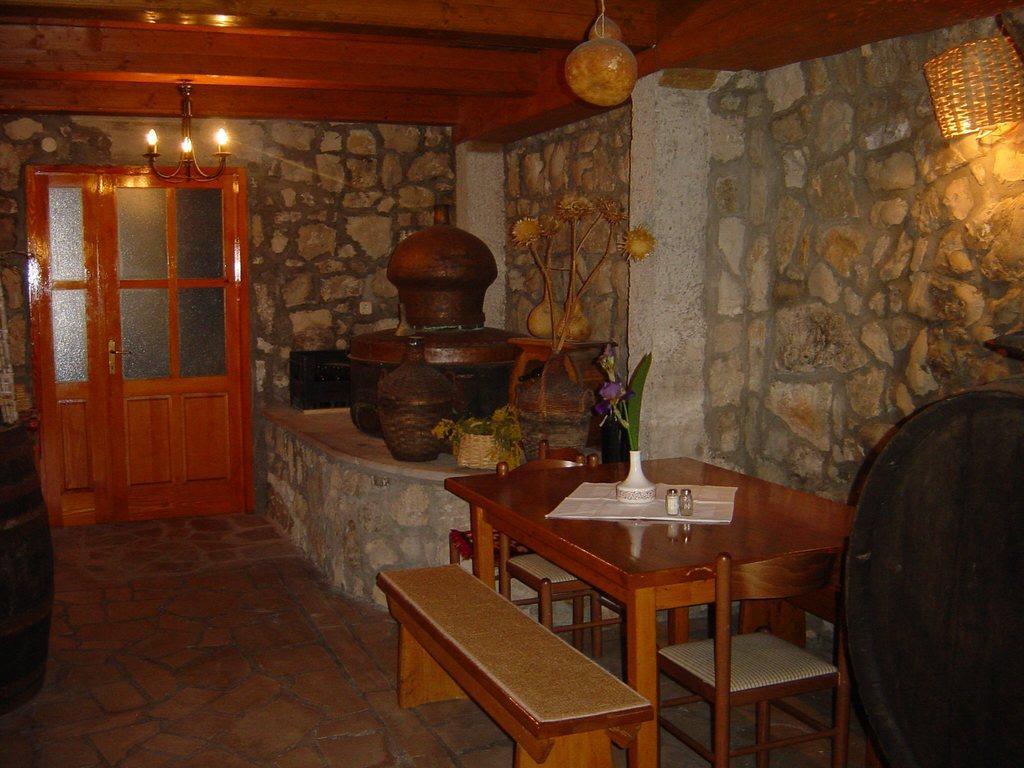Could you give a brief overview of what you see in this image? In this room there is a dining table there are chairs around it and a bench is there. behind it there is a pot. On the left there is a door. On the roof there is light. On the table there is a pot and bottles. 